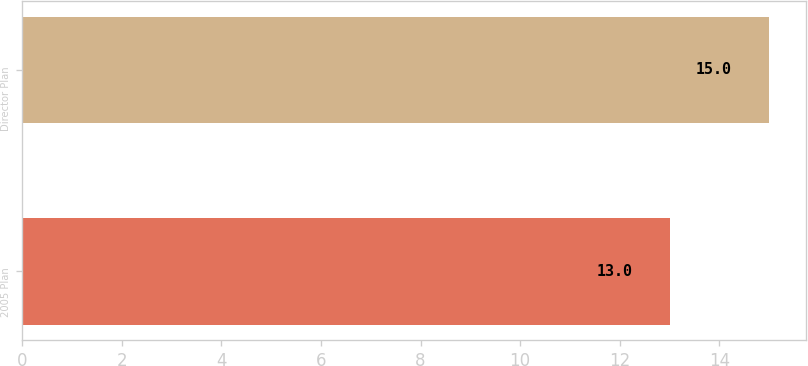<chart> <loc_0><loc_0><loc_500><loc_500><bar_chart><fcel>2005 Plan<fcel>Director Plan<nl><fcel>13<fcel>15<nl></chart> 